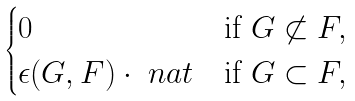<formula> <loc_0><loc_0><loc_500><loc_500>\begin{cases} 0 & \text {if } G \not \subset F , \\ \epsilon ( G , F ) \cdot \ n a t & \text {if } G \subset F , \end{cases}</formula> 